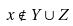Convert formula to latex. <formula><loc_0><loc_0><loc_500><loc_500>x \notin Y \cup Z</formula> 